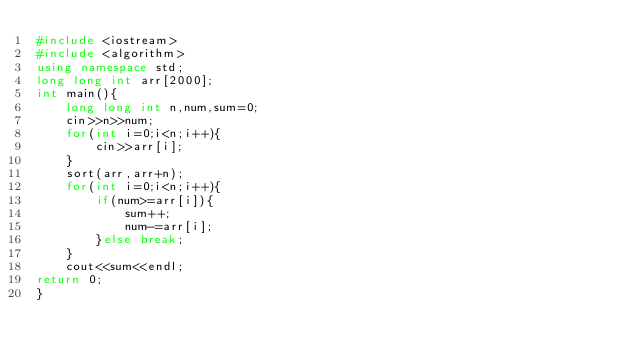Convert code to text. <code><loc_0><loc_0><loc_500><loc_500><_C++_>#include <iostream>
#include <algorithm>
using namespace std;
long long int arr[2000];
int main(){
    long long int n,num,sum=0;
    cin>>n>>num;
    for(int i=0;i<n;i++){
        cin>>arr[i];
    }
    sort(arr,arr+n);
    for(int i=0;i<n;i++){
        if(num>=arr[i]){
            sum++;
            num-=arr[i];
        }else break;
    }
    cout<<sum<<endl;
return 0;
}
</code> 